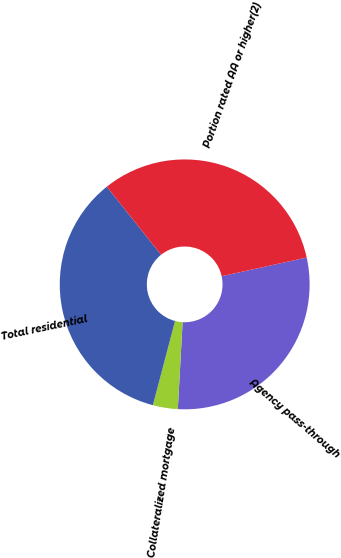Convert chart to OTSL. <chart><loc_0><loc_0><loc_500><loc_500><pie_chart><fcel>Agency pass-through<fcel>Collateralized mortgage<fcel>Total residential<fcel>Portion rated AA or higher(2)<nl><fcel>29.33%<fcel>3.22%<fcel>35.19%<fcel>32.26%<nl></chart> 